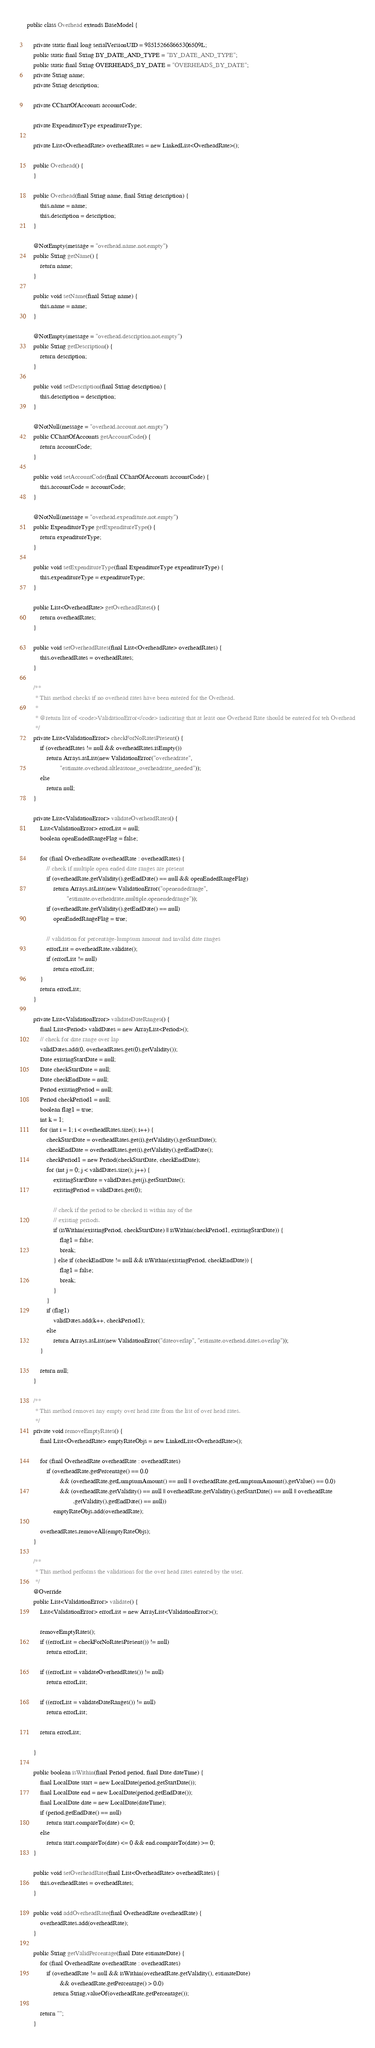Convert code to text. <code><loc_0><loc_0><loc_500><loc_500><_Java_>public class Overhead extends BaseModel {

    private static final long serialVersionUID = 985152668665306509L;
    public static final String BY_DATE_AND_TYPE = "BY_DATE_AND_TYPE";
    public static final String OVERHEADS_BY_DATE = "OVERHEADS_BY_DATE";
    private String name;
    private String description;

    private CChartOfAccounts accountCode;

    private ExpenditureType expenditureType;

    private List<OverheadRate> overheadRates = new LinkedList<OverheadRate>();

    public Overhead() {
    }

    public Overhead(final String name, final String description) {
        this.name = name;
        this.description = description;
    }

    @NotEmpty(message = "overhead.name.not.empty")
    public String getName() {
        return name;
    }

    public void setName(final String name) {
        this.name = name;
    }

    @NotEmpty(message = "overhead.description.not.empty")
    public String getDescription() {
        return description;
    }

    public void setDescription(final String description) {
        this.description = description;
    }

    @NotNull(message = "overhead.account.not.empty")
    public CChartOfAccounts getAccountCode() {
        return accountCode;
    }

    public void setAccountCode(final CChartOfAccounts accountCode) {
        this.accountCode = accountCode;
    }

    @NotNull(message = "overhead.expenditure.not.empty")
    public ExpenditureType getExpenditureType() {
        return expenditureType;
    }

    public void setExpenditureType(final ExpenditureType expenditureType) {
        this.expenditureType = expenditureType;
    }

    public List<OverheadRate> getOverheadRates() {
        return overheadRates;
    }

    public void setOverheadRates(final List<OverheadRate> overheadRates) {
        this.overheadRates = overheadRates;
    }

    /**
     * This method checks if no overhead rates have been entered for the Overhead.
     *
     * @return list of <code>ValidationError</code> indicating that at least one Overhead Rate should be entered for teh Overhead
     */
    private List<ValidationError> checkForNoRatesPresent() {
        if (overheadRates != null && overheadRates.isEmpty())
            return Arrays.asList(new ValidationError("overheadrate",
                    "estimate.overhead.altleastone_overheadrate_needed"));
        else
            return null;
    }

    private List<ValidationError> validateOverheadRates() {
        List<ValidationError> errorList = null;
        boolean openEndedRangeFlag = false;

        for (final OverheadRate overheadRate : overheadRates) {
            // check if multiple open ended date ranges are present
            if (overheadRate.getValidity().getEndDate() == null && openEndedRangeFlag)
                return Arrays.asList(new ValidationError("openendedrange",
                        "estimate.overheadrate.multiple.openendedrange"));
            if (overheadRate.getValidity().getEndDate() == null)
                openEndedRangeFlag = true;

            // validation for percentage-lumpsum amount and invalid date ranges
            errorList = overheadRate.validate();
            if (errorList != null)
                return errorList;
        }
        return errorList;
    }

    private List<ValidationError> validateDateRanges() {
        final List<Period> validDates = new ArrayList<Period>();
        // check for date range over lap
        validDates.add(0, overheadRates.get(0).getValidity());
        Date existingStartDate = null;
        Date checkStartDate = null;
        Date checkEndDate = null;
        Period existingPeriod = null;
        Period checkPeriod1 = null;
        boolean flag1 = true;
        int k = 1;
        for (int i = 1; i < overheadRates.size(); i++) {
            checkStartDate = overheadRates.get(i).getValidity().getStartDate();
            checkEndDate = overheadRates.get(i).getValidity().getEndDate();
            checkPeriod1 = new Period(checkStartDate, checkEndDate);
            for (int j = 0; j < validDates.size(); j++) {
                existingStartDate = validDates.get(j).getStartDate();
                existingPeriod = validDates.get(0);

                // check if the period to be checked is within any of the
                // existing periods.
                if (isWithin(existingPeriod, checkStartDate) || isWithin(checkPeriod1, existingStartDate)) {
                    flag1 = false;
                    break;
                } else if (checkEndDate != null && isWithin(existingPeriod, checkEndDate)) {
                    flag1 = false;
                    break;
                }
            }
            if (flag1)
                validDates.add(k++, checkPeriod1);
            else
                return Arrays.asList(new ValidationError("dateoverlap", "estimate.overhead.dates.overlap"));
        }

        return null;
    }

    /**
     * This method removes any empty over head rate from the list of over head rates.
     */
    private void removeEmptyRates() {
        final List<OverheadRate> emptyRateObjs = new LinkedList<OverheadRate>();

        for (final OverheadRate overheadRate : overheadRates)
            if (overheadRate.getPercentage() == 0.0
                    && (overheadRate.getLumpsumAmount() == null || overheadRate.getLumpsumAmount().getValue() == 0.0)
                    && (overheadRate.getValidity() == null || overheadRate.getValidity().getStartDate() == null || overheadRate
                            .getValidity().getEndDate() == null))
                emptyRateObjs.add(overheadRate);

        overheadRates.removeAll(emptyRateObjs);
    }

    /**
     * This method performs the validations for the over head rates entered by the user.
     */
    @Override
    public List<ValidationError> validate() {
        List<ValidationError> errorList = new ArrayList<ValidationError>();

        removeEmptyRates();
        if ((errorList = checkForNoRatesPresent()) != null)
            return errorList;

        if ((errorList = validateOverheadRates()) != null)
            return errorList;

        if ((errorList = validateDateRanges()) != null)
            return errorList;

        return errorList;

    }

    public boolean isWithin(final Period period, final Date dateTime) {
        final LocalDate start = new LocalDate(period.getStartDate());
        final LocalDate end = new LocalDate(period.getEndDate());
        final LocalDate date = new LocalDate(dateTime);
        if (period.getEndDate() == null)
            return start.compareTo(date) <= 0;
        else
            return start.compareTo(date) <= 0 && end.compareTo(date) >= 0;
    }

    public void setOverheadRate(final List<OverheadRate> overheadRates) {
        this.overheadRates = overheadRates;
    }

    public void addOverheadRate(final OverheadRate overheadRate) {
        overheadRates.add(overheadRate);
    }

    public String getValidPercentage(final Date estimateDate) {
        for (final OverheadRate overheadRate : overheadRates)
            if (overheadRate != null && isWithin(overheadRate.getValidity(), estimateDate)
                    && overheadRate.getPercentage() > 0.0)
                return String.valueOf(overheadRate.getPercentage());

        return "";
    }
</code> 